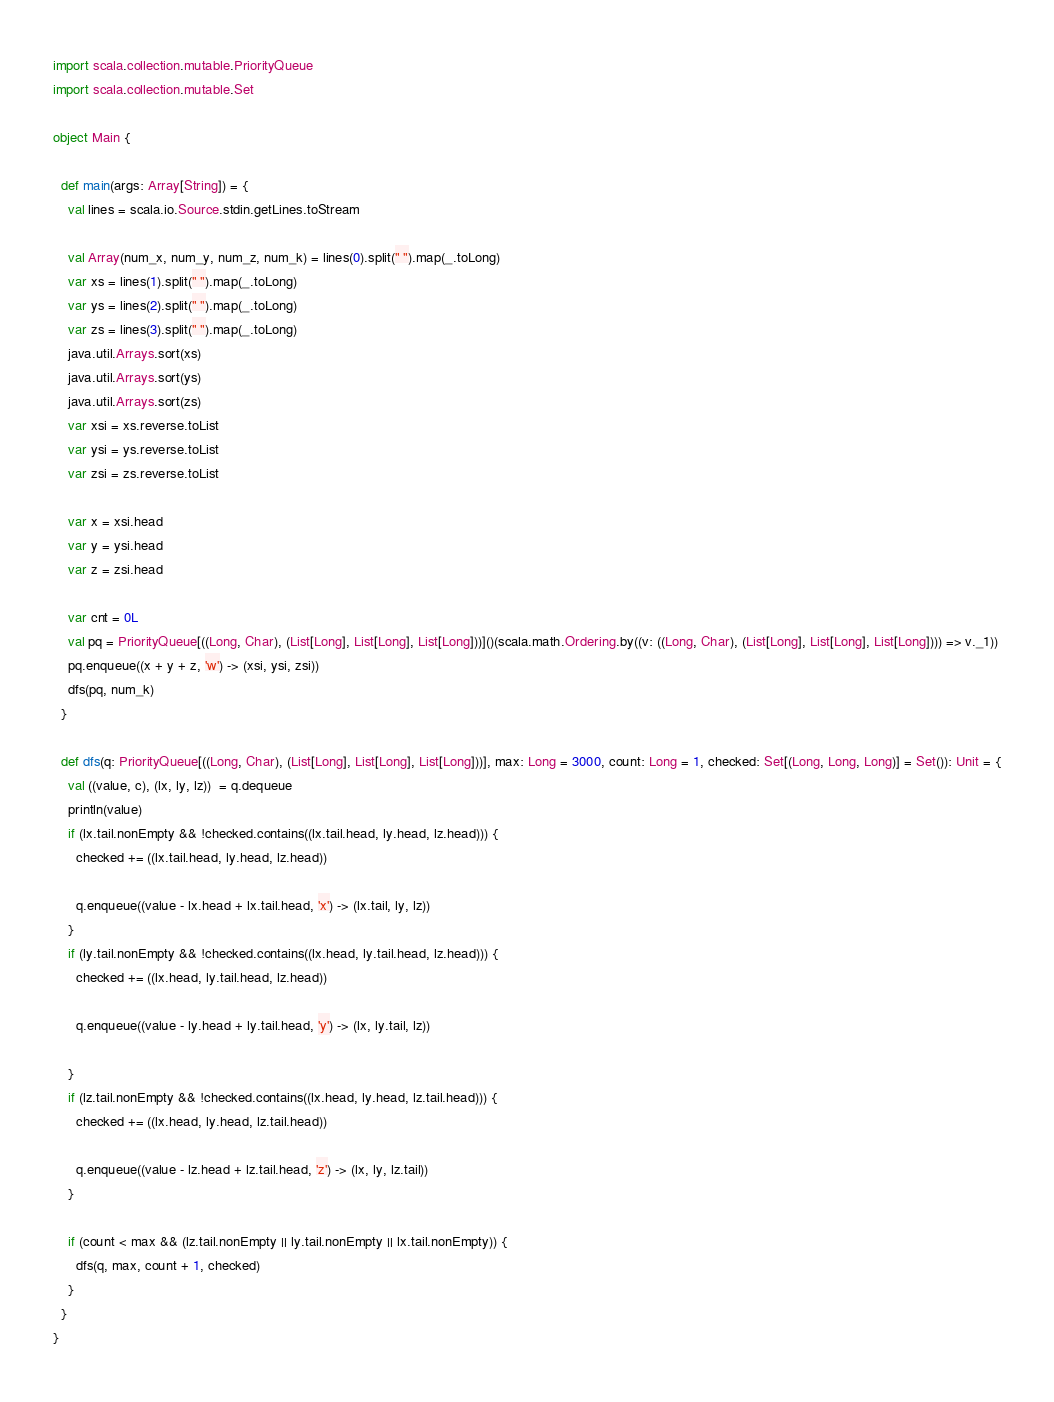Convert code to text. <code><loc_0><loc_0><loc_500><loc_500><_Scala_>import scala.collection.mutable.PriorityQueue
import scala.collection.mutable.Set

object Main {

  def main(args: Array[String]) = {
    val lines = scala.io.Source.stdin.getLines.toStream

    val Array(num_x, num_y, num_z, num_k) = lines(0).split(" ").map(_.toLong)
    var xs = lines(1).split(" ").map(_.toLong)
    var ys = lines(2).split(" ").map(_.toLong)
    var zs = lines(3).split(" ").map(_.toLong)
    java.util.Arrays.sort(xs)
    java.util.Arrays.sort(ys)
    java.util.Arrays.sort(zs)
    var xsi = xs.reverse.toList
    var ysi = ys.reverse.toList
    var zsi = zs.reverse.toList

    var x = xsi.head
    var y = ysi.head
    var z = zsi.head

    var cnt = 0L
    val pq = PriorityQueue[((Long, Char), (List[Long], List[Long], List[Long]))]()(scala.math.Ordering.by((v: ((Long, Char), (List[Long], List[Long], List[Long]))) => v._1))
    pq.enqueue((x + y + z, 'w') -> (xsi, ysi, zsi))
    dfs(pq, num_k)
  }

  def dfs(q: PriorityQueue[((Long, Char), (List[Long], List[Long], List[Long]))], max: Long = 3000, count: Long = 1, checked: Set[(Long, Long, Long)] = Set()): Unit = {
    val ((value, c), (lx, ly, lz))  = q.dequeue
    println(value)
    if (lx.tail.nonEmpty && !checked.contains((lx.tail.head, ly.head, lz.head))) {
      checked += ((lx.tail.head, ly.head, lz.head))

      q.enqueue((value - lx.head + lx.tail.head, 'x') -> (lx.tail, ly, lz))
    }
    if (ly.tail.nonEmpty && !checked.contains((lx.head, ly.tail.head, lz.head))) {
      checked += ((lx.head, ly.tail.head, lz.head))

      q.enqueue((value - ly.head + ly.tail.head, 'y') -> (lx, ly.tail, lz))

    }
    if (lz.tail.nonEmpty && !checked.contains((lx.head, ly.head, lz.tail.head))) {
      checked += ((lx.head, ly.head, lz.tail.head))

      q.enqueue((value - lz.head + lz.tail.head, 'z') -> (lx, ly, lz.tail))
    }

    if (count < max && (lz.tail.nonEmpty || ly.tail.nonEmpty || lx.tail.nonEmpty)) {
      dfs(q, max, count + 1, checked)
    }
  }
}
</code> 